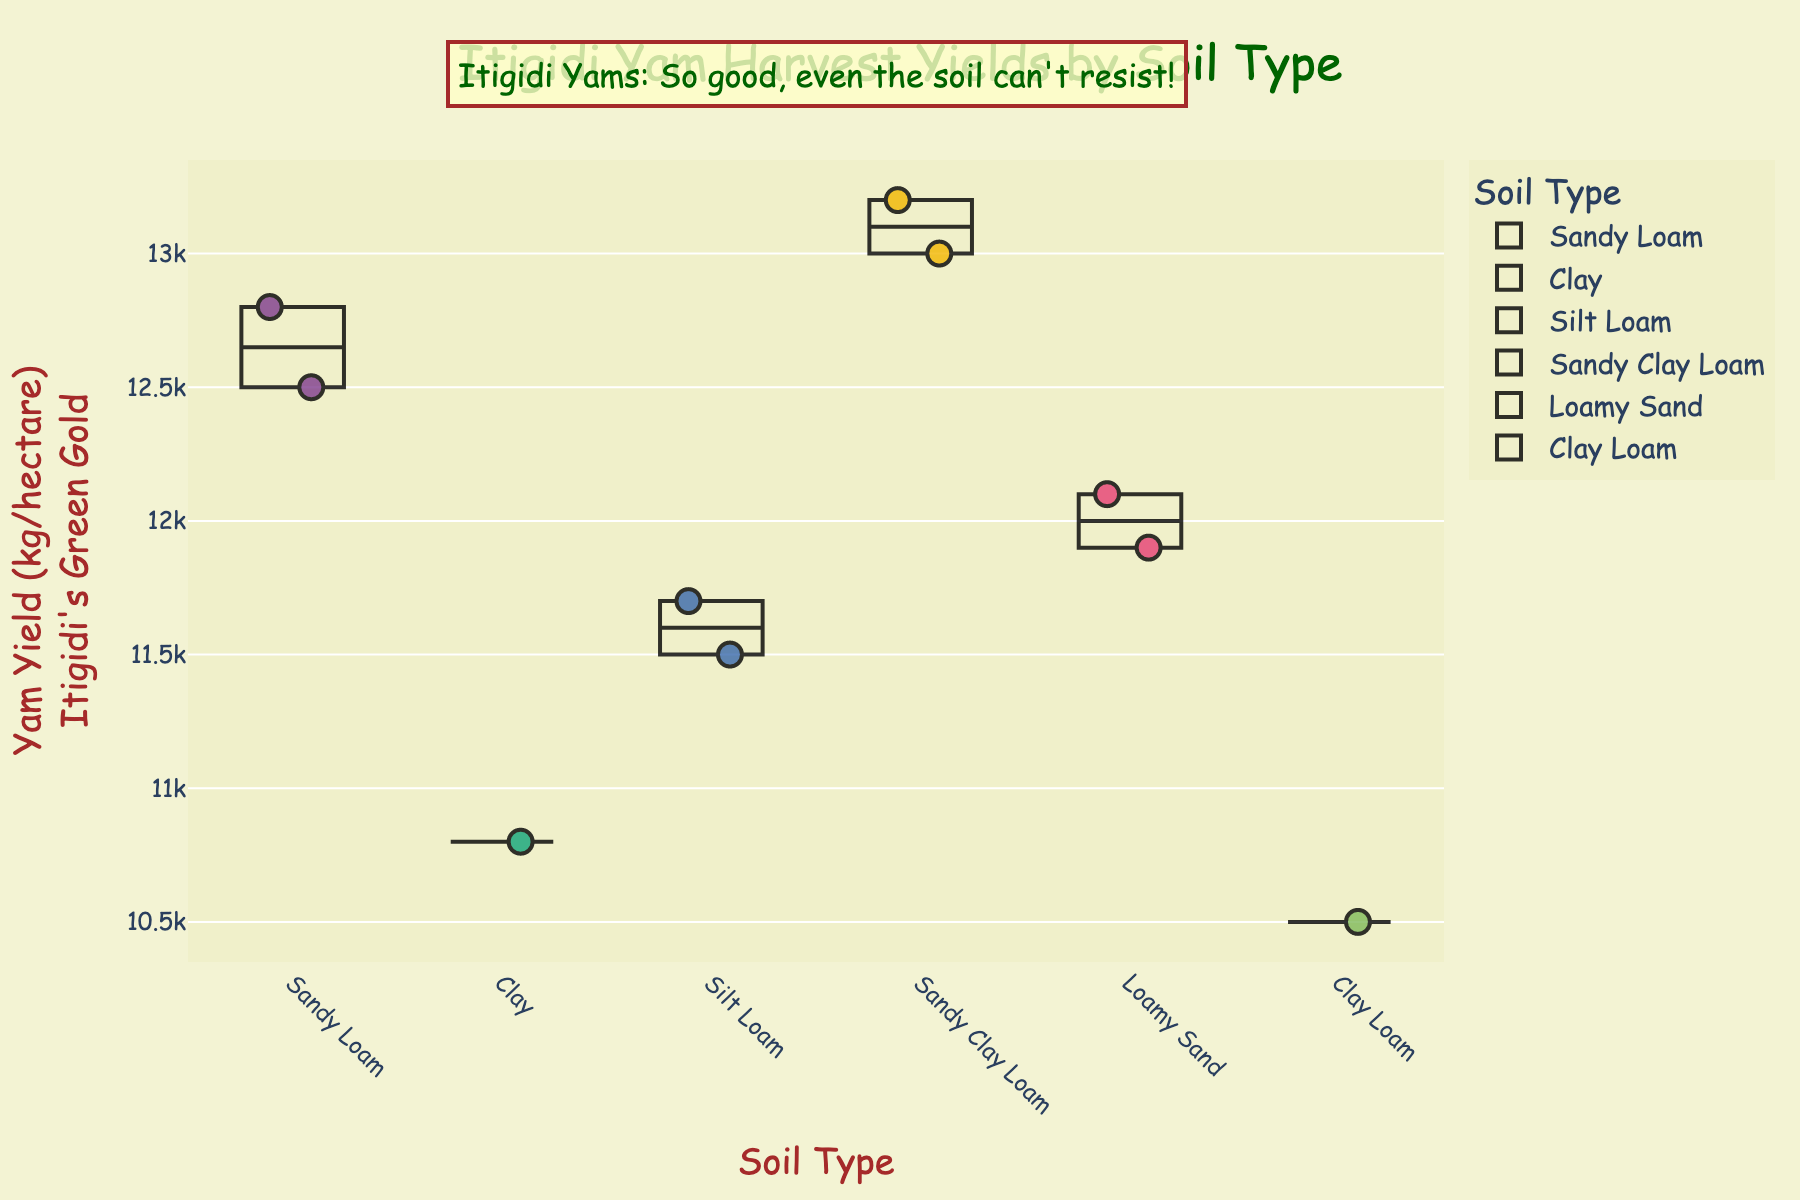What's the title of the figure? The title is usually placed at the top center of the figure for easy identification. Based on its appearance, the title can be directly read.
Answer: Itigidi Yam Harvest Yields by Soil Type Which farm has the highest yam yield? Looking at the data points and hovering or checking their values, you can identify the farm with the largest number on the y-axis.
Answer: Chief Okon's Land How is the yam yield distributed among farms with Sandy Loam soil? By examining the points under the "Sandy Loam" category, we identify their values which are 12500 and 12800 kg/hectare.
Answer: 12500, 12800 Which soil type has farms with the most varied yam yields? Compare the spread of yield values within each soil type category to determine variability. The category with the widest range is the one with the most varied yields.
Answer: Sandy Clay Loam What is the average yam yield for farms using Silt Loam soil? There are two data points for Silt Loam: 11700 and 11500. Adding them together gives 23200, and dividing by 2 gives the average.
Answer: 11600 How does Ekpo's Plantation's yam yield compare to Akpan's Estate's yam yield? By checking the data points for both farms and comparing their positions on the y-axis, you see that Ekpo's Plantation has 12800 kg/hectare and Akpan's Estate has 13000 kg/hectare.
Answer: Akpan's Estate has a higher yield Which soil type appears to have the highest median yam yield? For each soil type, list the yield values, and then find the median value. The median is the middle number when the values are sorted in ascending order.
Answer: Sandy Clay Loam Is there any humor incorporated into the figure? Identify visual elements or text that are meant to amuse the viewer. In this case, look for annotations or custom texts.
Answer: Yes, “Itigidi Yams: So good, even the soil can't resist!” What is the lowest yam yield recorded, and which farm does it belong to? Find the data point with the lowest value on the y-axis and note the corresponding farm name from the hover data.
Answer: 10500 kg/hectare, Mama Nneka's Farm 